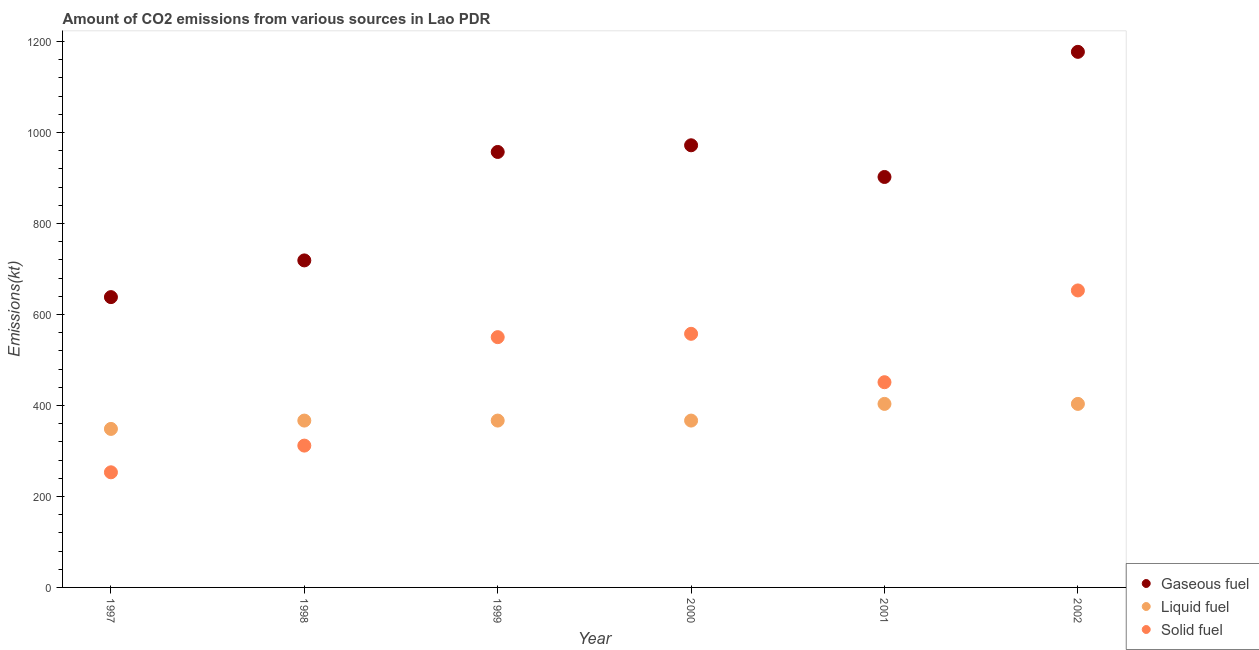What is the amount of co2 emissions from gaseous fuel in 2000?
Offer a terse response. 971.75. Across all years, what is the maximum amount of co2 emissions from liquid fuel?
Your answer should be compact. 403.37. Across all years, what is the minimum amount of co2 emissions from solid fuel?
Give a very brief answer. 253.02. In which year was the amount of co2 emissions from liquid fuel maximum?
Your answer should be very brief. 2001. What is the total amount of co2 emissions from gaseous fuel in the graph?
Offer a very short reply. 5364.82. What is the difference between the amount of co2 emissions from gaseous fuel in 1999 and that in 2000?
Your response must be concise. -14.67. What is the difference between the amount of co2 emissions from gaseous fuel in 2001 and the amount of co2 emissions from solid fuel in 1998?
Your response must be concise. 590.39. What is the average amount of co2 emissions from solid fuel per year?
Ensure brevity in your answer.  462.65. In the year 2001, what is the difference between the amount of co2 emissions from liquid fuel and amount of co2 emissions from gaseous fuel?
Your response must be concise. -498.71. Is the difference between the amount of co2 emissions from liquid fuel in 1999 and 2000 greater than the difference between the amount of co2 emissions from gaseous fuel in 1999 and 2000?
Make the answer very short. Yes. What is the difference between the highest and the second highest amount of co2 emissions from solid fuel?
Ensure brevity in your answer.  95.34. What is the difference between the highest and the lowest amount of co2 emissions from solid fuel?
Provide a short and direct response. 399.7. In how many years, is the amount of co2 emissions from solid fuel greater than the average amount of co2 emissions from solid fuel taken over all years?
Ensure brevity in your answer.  3. What is the difference between two consecutive major ticks on the Y-axis?
Keep it short and to the point. 200. Are the values on the major ticks of Y-axis written in scientific E-notation?
Keep it short and to the point. No. Does the graph contain grids?
Provide a short and direct response. No. How many legend labels are there?
Give a very brief answer. 3. What is the title of the graph?
Provide a succinct answer. Amount of CO2 emissions from various sources in Lao PDR. Does "Agricultural Nitrous Oxide" appear as one of the legend labels in the graph?
Your response must be concise. No. What is the label or title of the Y-axis?
Keep it short and to the point. Emissions(kt). What is the Emissions(kt) of Gaseous fuel in 1997?
Keep it short and to the point. 638.06. What is the Emissions(kt) in Liquid fuel in 1997?
Offer a very short reply. 348.37. What is the Emissions(kt) in Solid fuel in 1997?
Your answer should be very brief. 253.02. What is the Emissions(kt) of Gaseous fuel in 1998?
Offer a very short reply. 718.73. What is the Emissions(kt) in Liquid fuel in 1998?
Keep it short and to the point. 366.7. What is the Emissions(kt) in Solid fuel in 1998?
Make the answer very short. 311.69. What is the Emissions(kt) of Gaseous fuel in 1999?
Your response must be concise. 957.09. What is the Emissions(kt) in Liquid fuel in 1999?
Give a very brief answer. 366.7. What is the Emissions(kt) in Solid fuel in 1999?
Offer a terse response. 550.05. What is the Emissions(kt) of Gaseous fuel in 2000?
Offer a very short reply. 971.75. What is the Emissions(kt) in Liquid fuel in 2000?
Provide a succinct answer. 366.7. What is the Emissions(kt) of Solid fuel in 2000?
Give a very brief answer. 557.38. What is the Emissions(kt) in Gaseous fuel in 2001?
Provide a succinct answer. 902.08. What is the Emissions(kt) of Liquid fuel in 2001?
Provide a succinct answer. 403.37. What is the Emissions(kt) of Solid fuel in 2001?
Provide a short and direct response. 451.04. What is the Emissions(kt) of Gaseous fuel in 2002?
Provide a succinct answer. 1177.11. What is the Emissions(kt) in Liquid fuel in 2002?
Keep it short and to the point. 403.37. What is the Emissions(kt) in Solid fuel in 2002?
Your response must be concise. 652.73. Across all years, what is the maximum Emissions(kt) of Gaseous fuel?
Keep it short and to the point. 1177.11. Across all years, what is the maximum Emissions(kt) of Liquid fuel?
Your answer should be very brief. 403.37. Across all years, what is the maximum Emissions(kt) in Solid fuel?
Your answer should be very brief. 652.73. Across all years, what is the minimum Emissions(kt) of Gaseous fuel?
Offer a very short reply. 638.06. Across all years, what is the minimum Emissions(kt) of Liquid fuel?
Your response must be concise. 348.37. Across all years, what is the minimum Emissions(kt) in Solid fuel?
Offer a terse response. 253.02. What is the total Emissions(kt) in Gaseous fuel in the graph?
Give a very brief answer. 5364.82. What is the total Emissions(kt) in Liquid fuel in the graph?
Offer a terse response. 2255.2. What is the total Emissions(kt) in Solid fuel in the graph?
Keep it short and to the point. 2775.92. What is the difference between the Emissions(kt) of Gaseous fuel in 1997 and that in 1998?
Give a very brief answer. -80.67. What is the difference between the Emissions(kt) in Liquid fuel in 1997 and that in 1998?
Provide a succinct answer. -18.34. What is the difference between the Emissions(kt) in Solid fuel in 1997 and that in 1998?
Your answer should be compact. -58.67. What is the difference between the Emissions(kt) in Gaseous fuel in 1997 and that in 1999?
Make the answer very short. -319.03. What is the difference between the Emissions(kt) in Liquid fuel in 1997 and that in 1999?
Offer a terse response. -18.34. What is the difference between the Emissions(kt) of Solid fuel in 1997 and that in 1999?
Keep it short and to the point. -297.03. What is the difference between the Emissions(kt) of Gaseous fuel in 1997 and that in 2000?
Provide a succinct answer. -333.7. What is the difference between the Emissions(kt) in Liquid fuel in 1997 and that in 2000?
Give a very brief answer. -18.34. What is the difference between the Emissions(kt) of Solid fuel in 1997 and that in 2000?
Give a very brief answer. -304.36. What is the difference between the Emissions(kt) in Gaseous fuel in 1997 and that in 2001?
Your response must be concise. -264.02. What is the difference between the Emissions(kt) of Liquid fuel in 1997 and that in 2001?
Keep it short and to the point. -55.01. What is the difference between the Emissions(kt) of Solid fuel in 1997 and that in 2001?
Provide a succinct answer. -198.02. What is the difference between the Emissions(kt) in Gaseous fuel in 1997 and that in 2002?
Provide a succinct answer. -539.05. What is the difference between the Emissions(kt) in Liquid fuel in 1997 and that in 2002?
Offer a very short reply. -55.01. What is the difference between the Emissions(kt) in Solid fuel in 1997 and that in 2002?
Your response must be concise. -399.7. What is the difference between the Emissions(kt) in Gaseous fuel in 1998 and that in 1999?
Provide a succinct answer. -238.35. What is the difference between the Emissions(kt) in Liquid fuel in 1998 and that in 1999?
Provide a succinct answer. 0. What is the difference between the Emissions(kt) of Solid fuel in 1998 and that in 1999?
Give a very brief answer. -238.35. What is the difference between the Emissions(kt) of Gaseous fuel in 1998 and that in 2000?
Your answer should be very brief. -253.02. What is the difference between the Emissions(kt) of Liquid fuel in 1998 and that in 2000?
Make the answer very short. 0. What is the difference between the Emissions(kt) of Solid fuel in 1998 and that in 2000?
Offer a terse response. -245.69. What is the difference between the Emissions(kt) of Gaseous fuel in 1998 and that in 2001?
Offer a very short reply. -183.35. What is the difference between the Emissions(kt) of Liquid fuel in 1998 and that in 2001?
Keep it short and to the point. -36.67. What is the difference between the Emissions(kt) of Solid fuel in 1998 and that in 2001?
Provide a short and direct response. -139.35. What is the difference between the Emissions(kt) in Gaseous fuel in 1998 and that in 2002?
Provide a short and direct response. -458.38. What is the difference between the Emissions(kt) in Liquid fuel in 1998 and that in 2002?
Make the answer very short. -36.67. What is the difference between the Emissions(kt) in Solid fuel in 1998 and that in 2002?
Your answer should be very brief. -341.03. What is the difference between the Emissions(kt) of Gaseous fuel in 1999 and that in 2000?
Make the answer very short. -14.67. What is the difference between the Emissions(kt) in Solid fuel in 1999 and that in 2000?
Your answer should be compact. -7.33. What is the difference between the Emissions(kt) of Gaseous fuel in 1999 and that in 2001?
Offer a terse response. 55.01. What is the difference between the Emissions(kt) of Liquid fuel in 1999 and that in 2001?
Ensure brevity in your answer.  -36.67. What is the difference between the Emissions(kt) of Solid fuel in 1999 and that in 2001?
Provide a short and direct response. 99.01. What is the difference between the Emissions(kt) of Gaseous fuel in 1999 and that in 2002?
Your answer should be compact. -220.02. What is the difference between the Emissions(kt) of Liquid fuel in 1999 and that in 2002?
Your answer should be very brief. -36.67. What is the difference between the Emissions(kt) in Solid fuel in 1999 and that in 2002?
Provide a short and direct response. -102.68. What is the difference between the Emissions(kt) in Gaseous fuel in 2000 and that in 2001?
Give a very brief answer. 69.67. What is the difference between the Emissions(kt) of Liquid fuel in 2000 and that in 2001?
Your answer should be compact. -36.67. What is the difference between the Emissions(kt) in Solid fuel in 2000 and that in 2001?
Offer a very short reply. 106.34. What is the difference between the Emissions(kt) in Gaseous fuel in 2000 and that in 2002?
Give a very brief answer. -205.35. What is the difference between the Emissions(kt) in Liquid fuel in 2000 and that in 2002?
Provide a short and direct response. -36.67. What is the difference between the Emissions(kt) in Solid fuel in 2000 and that in 2002?
Your answer should be compact. -95.34. What is the difference between the Emissions(kt) in Gaseous fuel in 2001 and that in 2002?
Offer a terse response. -275.02. What is the difference between the Emissions(kt) in Liquid fuel in 2001 and that in 2002?
Give a very brief answer. 0. What is the difference between the Emissions(kt) of Solid fuel in 2001 and that in 2002?
Give a very brief answer. -201.69. What is the difference between the Emissions(kt) of Gaseous fuel in 1997 and the Emissions(kt) of Liquid fuel in 1998?
Ensure brevity in your answer.  271.36. What is the difference between the Emissions(kt) of Gaseous fuel in 1997 and the Emissions(kt) of Solid fuel in 1998?
Keep it short and to the point. 326.36. What is the difference between the Emissions(kt) in Liquid fuel in 1997 and the Emissions(kt) in Solid fuel in 1998?
Your answer should be compact. 36.67. What is the difference between the Emissions(kt) of Gaseous fuel in 1997 and the Emissions(kt) of Liquid fuel in 1999?
Your response must be concise. 271.36. What is the difference between the Emissions(kt) in Gaseous fuel in 1997 and the Emissions(kt) in Solid fuel in 1999?
Offer a terse response. 88.01. What is the difference between the Emissions(kt) of Liquid fuel in 1997 and the Emissions(kt) of Solid fuel in 1999?
Provide a short and direct response. -201.69. What is the difference between the Emissions(kt) in Gaseous fuel in 1997 and the Emissions(kt) in Liquid fuel in 2000?
Your answer should be very brief. 271.36. What is the difference between the Emissions(kt) in Gaseous fuel in 1997 and the Emissions(kt) in Solid fuel in 2000?
Your answer should be compact. 80.67. What is the difference between the Emissions(kt) of Liquid fuel in 1997 and the Emissions(kt) of Solid fuel in 2000?
Offer a terse response. -209.02. What is the difference between the Emissions(kt) of Gaseous fuel in 1997 and the Emissions(kt) of Liquid fuel in 2001?
Ensure brevity in your answer.  234.69. What is the difference between the Emissions(kt) of Gaseous fuel in 1997 and the Emissions(kt) of Solid fuel in 2001?
Your response must be concise. 187.02. What is the difference between the Emissions(kt) of Liquid fuel in 1997 and the Emissions(kt) of Solid fuel in 2001?
Make the answer very short. -102.68. What is the difference between the Emissions(kt) of Gaseous fuel in 1997 and the Emissions(kt) of Liquid fuel in 2002?
Keep it short and to the point. 234.69. What is the difference between the Emissions(kt) of Gaseous fuel in 1997 and the Emissions(kt) of Solid fuel in 2002?
Offer a very short reply. -14.67. What is the difference between the Emissions(kt) of Liquid fuel in 1997 and the Emissions(kt) of Solid fuel in 2002?
Your response must be concise. -304.36. What is the difference between the Emissions(kt) of Gaseous fuel in 1998 and the Emissions(kt) of Liquid fuel in 1999?
Your answer should be very brief. 352.03. What is the difference between the Emissions(kt) of Gaseous fuel in 1998 and the Emissions(kt) of Solid fuel in 1999?
Your answer should be compact. 168.68. What is the difference between the Emissions(kt) in Liquid fuel in 1998 and the Emissions(kt) in Solid fuel in 1999?
Ensure brevity in your answer.  -183.35. What is the difference between the Emissions(kt) of Gaseous fuel in 1998 and the Emissions(kt) of Liquid fuel in 2000?
Provide a succinct answer. 352.03. What is the difference between the Emissions(kt) of Gaseous fuel in 1998 and the Emissions(kt) of Solid fuel in 2000?
Provide a succinct answer. 161.35. What is the difference between the Emissions(kt) in Liquid fuel in 1998 and the Emissions(kt) in Solid fuel in 2000?
Your answer should be very brief. -190.68. What is the difference between the Emissions(kt) in Gaseous fuel in 1998 and the Emissions(kt) in Liquid fuel in 2001?
Your answer should be compact. 315.36. What is the difference between the Emissions(kt) in Gaseous fuel in 1998 and the Emissions(kt) in Solid fuel in 2001?
Provide a short and direct response. 267.69. What is the difference between the Emissions(kt) of Liquid fuel in 1998 and the Emissions(kt) of Solid fuel in 2001?
Offer a very short reply. -84.34. What is the difference between the Emissions(kt) of Gaseous fuel in 1998 and the Emissions(kt) of Liquid fuel in 2002?
Offer a very short reply. 315.36. What is the difference between the Emissions(kt) of Gaseous fuel in 1998 and the Emissions(kt) of Solid fuel in 2002?
Keep it short and to the point. 66.01. What is the difference between the Emissions(kt) in Liquid fuel in 1998 and the Emissions(kt) in Solid fuel in 2002?
Keep it short and to the point. -286.03. What is the difference between the Emissions(kt) in Gaseous fuel in 1999 and the Emissions(kt) in Liquid fuel in 2000?
Your response must be concise. 590.39. What is the difference between the Emissions(kt) of Gaseous fuel in 1999 and the Emissions(kt) of Solid fuel in 2000?
Ensure brevity in your answer.  399.7. What is the difference between the Emissions(kt) in Liquid fuel in 1999 and the Emissions(kt) in Solid fuel in 2000?
Ensure brevity in your answer.  -190.68. What is the difference between the Emissions(kt) of Gaseous fuel in 1999 and the Emissions(kt) of Liquid fuel in 2001?
Your answer should be very brief. 553.72. What is the difference between the Emissions(kt) of Gaseous fuel in 1999 and the Emissions(kt) of Solid fuel in 2001?
Keep it short and to the point. 506.05. What is the difference between the Emissions(kt) in Liquid fuel in 1999 and the Emissions(kt) in Solid fuel in 2001?
Your response must be concise. -84.34. What is the difference between the Emissions(kt) of Gaseous fuel in 1999 and the Emissions(kt) of Liquid fuel in 2002?
Give a very brief answer. 553.72. What is the difference between the Emissions(kt) of Gaseous fuel in 1999 and the Emissions(kt) of Solid fuel in 2002?
Offer a very short reply. 304.36. What is the difference between the Emissions(kt) in Liquid fuel in 1999 and the Emissions(kt) in Solid fuel in 2002?
Offer a terse response. -286.03. What is the difference between the Emissions(kt) in Gaseous fuel in 2000 and the Emissions(kt) in Liquid fuel in 2001?
Provide a short and direct response. 568.38. What is the difference between the Emissions(kt) of Gaseous fuel in 2000 and the Emissions(kt) of Solid fuel in 2001?
Offer a terse response. 520.71. What is the difference between the Emissions(kt) of Liquid fuel in 2000 and the Emissions(kt) of Solid fuel in 2001?
Your answer should be compact. -84.34. What is the difference between the Emissions(kt) in Gaseous fuel in 2000 and the Emissions(kt) in Liquid fuel in 2002?
Provide a succinct answer. 568.38. What is the difference between the Emissions(kt) in Gaseous fuel in 2000 and the Emissions(kt) in Solid fuel in 2002?
Give a very brief answer. 319.03. What is the difference between the Emissions(kt) of Liquid fuel in 2000 and the Emissions(kt) of Solid fuel in 2002?
Offer a terse response. -286.03. What is the difference between the Emissions(kt) of Gaseous fuel in 2001 and the Emissions(kt) of Liquid fuel in 2002?
Ensure brevity in your answer.  498.71. What is the difference between the Emissions(kt) of Gaseous fuel in 2001 and the Emissions(kt) of Solid fuel in 2002?
Your answer should be very brief. 249.36. What is the difference between the Emissions(kt) of Liquid fuel in 2001 and the Emissions(kt) of Solid fuel in 2002?
Provide a short and direct response. -249.36. What is the average Emissions(kt) of Gaseous fuel per year?
Make the answer very short. 894.14. What is the average Emissions(kt) in Liquid fuel per year?
Your answer should be very brief. 375.87. What is the average Emissions(kt) in Solid fuel per year?
Your answer should be compact. 462.65. In the year 1997, what is the difference between the Emissions(kt) of Gaseous fuel and Emissions(kt) of Liquid fuel?
Ensure brevity in your answer.  289.69. In the year 1997, what is the difference between the Emissions(kt) of Gaseous fuel and Emissions(kt) of Solid fuel?
Provide a short and direct response. 385.04. In the year 1997, what is the difference between the Emissions(kt) of Liquid fuel and Emissions(kt) of Solid fuel?
Your answer should be very brief. 95.34. In the year 1998, what is the difference between the Emissions(kt) in Gaseous fuel and Emissions(kt) in Liquid fuel?
Keep it short and to the point. 352.03. In the year 1998, what is the difference between the Emissions(kt) of Gaseous fuel and Emissions(kt) of Solid fuel?
Your answer should be compact. 407.04. In the year 1998, what is the difference between the Emissions(kt) of Liquid fuel and Emissions(kt) of Solid fuel?
Provide a succinct answer. 55.01. In the year 1999, what is the difference between the Emissions(kt) of Gaseous fuel and Emissions(kt) of Liquid fuel?
Keep it short and to the point. 590.39. In the year 1999, what is the difference between the Emissions(kt) in Gaseous fuel and Emissions(kt) in Solid fuel?
Your response must be concise. 407.04. In the year 1999, what is the difference between the Emissions(kt) in Liquid fuel and Emissions(kt) in Solid fuel?
Your response must be concise. -183.35. In the year 2000, what is the difference between the Emissions(kt) in Gaseous fuel and Emissions(kt) in Liquid fuel?
Ensure brevity in your answer.  605.05. In the year 2000, what is the difference between the Emissions(kt) of Gaseous fuel and Emissions(kt) of Solid fuel?
Your response must be concise. 414.37. In the year 2000, what is the difference between the Emissions(kt) in Liquid fuel and Emissions(kt) in Solid fuel?
Provide a succinct answer. -190.68. In the year 2001, what is the difference between the Emissions(kt) in Gaseous fuel and Emissions(kt) in Liquid fuel?
Your answer should be very brief. 498.71. In the year 2001, what is the difference between the Emissions(kt) of Gaseous fuel and Emissions(kt) of Solid fuel?
Your answer should be very brief. 451.04. In the year 2001, what is the difference between the Emissions(kt) in Liquid fuel and Emissions(kt) in Solid fuel?
Provide a succinct answer. -47.67. In the year 2002, what is the difference between the Emissions(kt) of Gaseous fuel and Emissions(kt) of Liquid fuel?
Your answer should be very brief. 773.74. In the year 2002, what is the difference between the Emissions(kt) in Gaseous fuel and Emissions(kt) in Solid fuel?
Your answer should be very brief. 524.38. In the year 2002, what is the difference between the Emissions(kt) of Liquid fuel and Emissions(kt) of Solid fuel?
Provide a succinct answer. -249.36. What is the ratio of the Emissions(kt) in Gaseous fuel in 1997 to that in 1998?
Your response must be concise. 0.89. What is the ratio of the Emissions(kt) in Solid fuel in 1997 to that in 1998?
Offer a very short reply. 0.81. What is the ratio of the Emissions(kt) in Gaseous fuel in 1997 to that in 1999?
Your response must be concise. 0.67. What is the ratio of the Emissions(kt) of Solid fuel in 1997 to that in 1999?
Provide a succinct answer. 0.46. What is the ratio of the Emissions(kt) in Gaseous fuel in 1997 to that in 2000?
Make the answer very short. 0.66. What is the ratio of the Emissions(kt) in Liquid fuel in 1997 to that in 2000?
Ensure brevity in your answer.  0.95. What is the ratio of the Emissions(kt) of Solid fuel in 1997 to that in 2000?
Provide a succinct answer. 0.45. What is the ratio of the Emissions(kt) of Gaseous fuel in 1997 to that in 2001?
Offer a terse response. 0.71. What is the ratio of the Emissions(kt) of Liquid fuel in 1997 to that in 2001?
Make the answer very short. 0.86. What is the ratio of the Emissions(kt) in Solid fuel in 1997 to that in 2001?
Keep it short and to the point. 0.56. What is the ratio of the Emissions(kt) of Gaseous fuel in 1997 to that in 2002?
Provide a short and direct response. 0.54. What is the ratio of the Emissions(kt) in Liquid fuel in 1997 to that in 2002?
Offer a terse response. 0.86. What is the ratio of the Emissions(kt) of Solid fuel in 1997 to that in 2002?
Provide a succinct answer. 0.39. What is the ratio of the Emissions(kt) of Gaseous fuel in 1998 to that in 1999?
Give a very brief answer. 0.75. What is the ratio of the Emissions(kt) in Solid fuel in 1998 to that in 1999?
Give a very brief answer. 0.57. What is the ratio of the Emissions(kt) of Gaseous fuel in 1998 to that in 2000?
Provide a succinct answer. 0.74. What is the ratio of the Emissions(kt) in Solid fuel in 1998 to that in 2000?
Keep it short and to the point. 0.56. What is the ratio of the Emissions(kt) in Gaseous fuel in 1998 to that in 2001?
Provide a short and direct response. 0.8. What is the ratio of the Emissions(kt) in Liquid fuel in 1998 to that in 2001?
Your answer should be compact. 0.91. What is the ratio of the Emissions(kt) in Solid fuel in 1998 to that in 2001?
Give a very brief answer. 0.69. What is the ratio of the Emissions(kt) of Gaseous fuel in 1998 to that in 2002?
Give a very brief answer. 0.61. What is the ratio of the Emissions(kt) of Solid fuel in 1998 to that in 2002?
Keep it short and to the point. 0.48. What is the ratio of the Emissions(kt) in Gaseous fuel in 1999 to that in 2000?
Your answer should be very brief. 0.98. What is the ratio of the Emissions(kt) of Solid fuel in 1999 to that in 2000?
Provide a succinct answer. 0.99. What is the ratio of the Emissions(kt) in Gaseous fuel in 1999 to that in 2001?
Offer a terse response. 1.06. What is the ratio of the Emissions(kt) in Liquid fuel in 1999 to that in 2001?
Your answer should be compact. 0.91. What is the ratio of the Emissions(kt) in Solid fuel in 1999 to that in 2001?
Provide a succinct answer. 1.22. What is the ratio of the Emissions(kt) of Gaseous fuel in 1999 to that in 2002?
Ensure brevity in your answer.  0.81. What is the ratio of the Emissions(kt) in Solid fuel in 1999 to that in 2002?
Your answer should be very brief. 0.84. What is the ratio of the Emissions(kt) of Gaseous fuel in 2000 to that in 2001?
Offer a very short reply. 1.08. What is the ratio of the Emissions(kt) in Solid fuel in 2000 to that in 2001?
Ensure brevity in your answer.  1.24. What is the ratio of the Emissions(kt) of Gaseous fuel in 2000 to that in 2002?
Offer a very short reply. 0.83. What is the ratio of the Emissions(kt) of Liquid fuel in 2000 to that in 2002?
Keep it short and to the point. 0.91. What is the ratio of the Emissions(kt) of Solid fuel in 2000 to that in 2002?
Ensure brevity in your answer.  0.85. What is the ratio of the Emissions(kt) in Gaseous fuel in 2001 to that in 2002?
Ensure brevity in your answer.  0.77. What is the ratio of the Emissions(kt) in Solid fuel in 2001 to that in 2002?
Offer a terse response. 0.69. What is the difference between the highest and the second highest Emissions(kt) of Gaseous fuel?
Your response must be concise. 205.35. What is the difference between the highest and the second highest Emissions(kt) in Liquid fuel?
Make the answer very short. 0. What is the difference between the highest and the second highest Emissions(kt) in Solid fuel?
Offer a terse response. 95.34. What is the difference between the highest and the lowest Emissions(kt) of Gaseous fuel?
Offer a very short reply. 539.05. What is the difference between the highest and the lowest Emissions(kt) of Liquid fuel?
Provide a succinct answer. 55.01. What is the difference between the highest and the lowest Emissions(kt) in Solid fuel?
Offer a terse response. 399.7. 